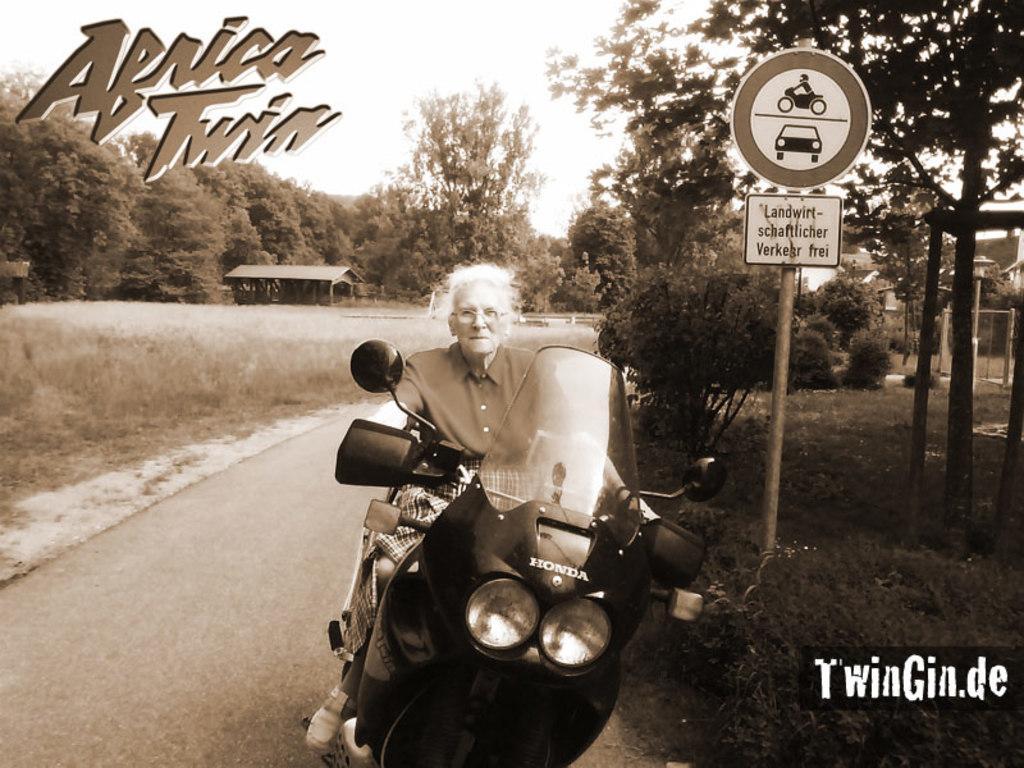Please provide a concise description of this image. It is an edited image,there is a woman riding a bike and beside her there is a caution board attached to a pole and around that there are lot of trees and grass and on the top left of the image it is written as "Africa twin". 